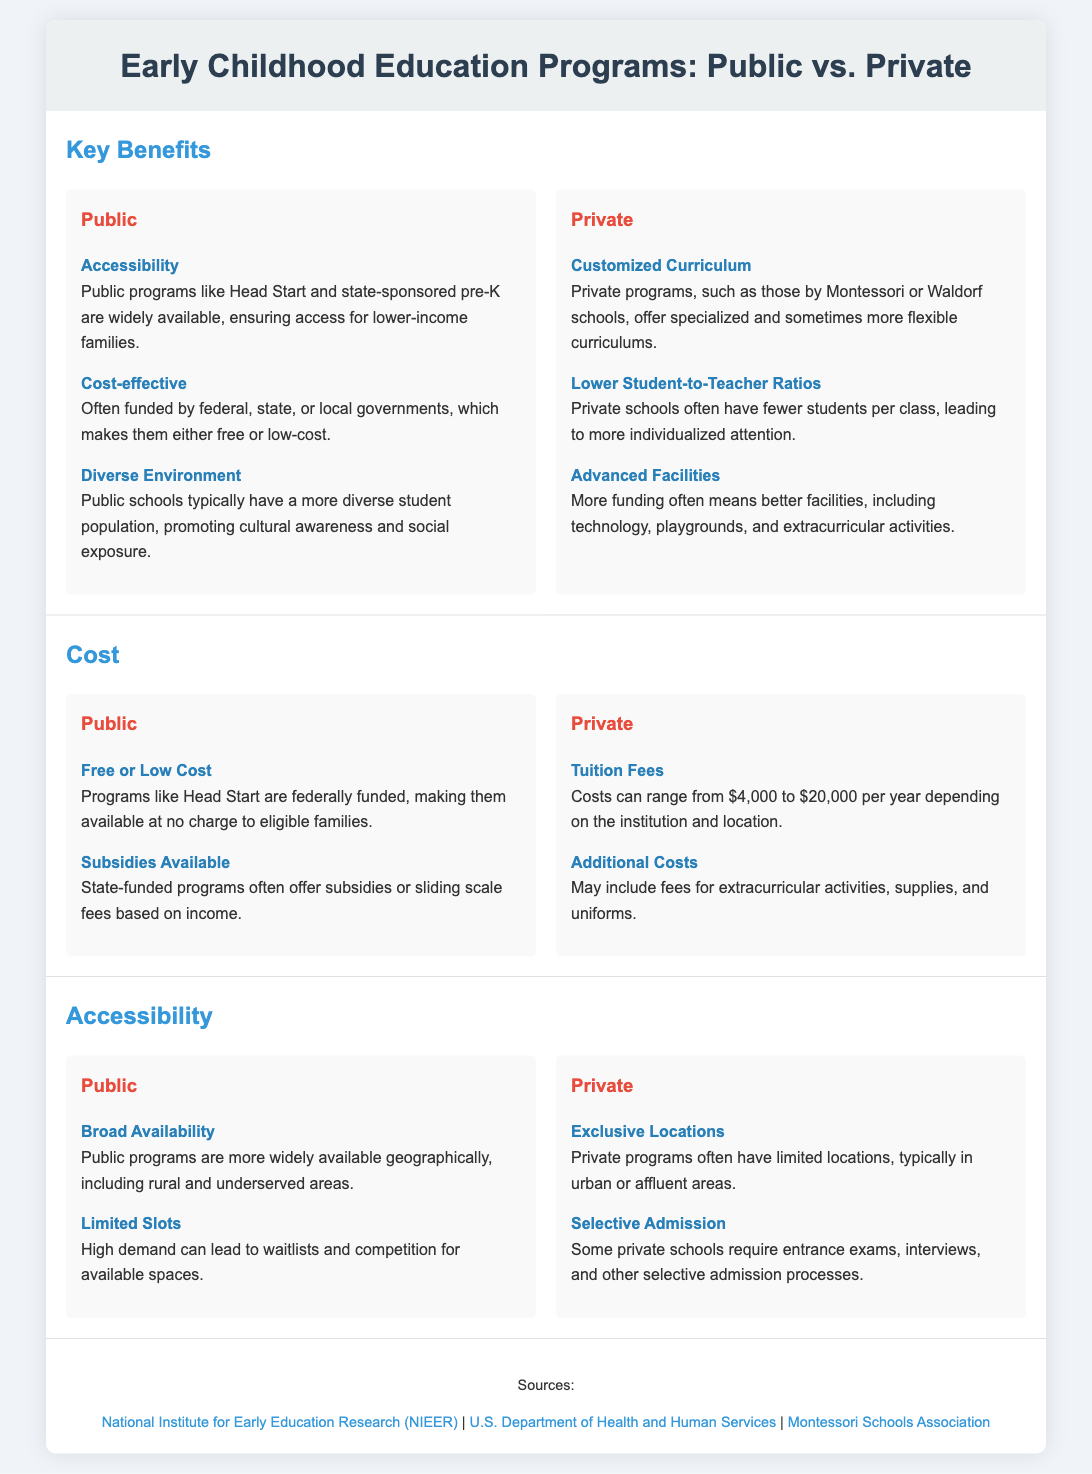What is a key benefit of public programs? The benefits listed for public programs include Accessibility, Cost-effective, and Diverse Environment.
Answer: Accessibility What is the range of tuition fees for private programs? The document states that costs can range from $4,000 to $20,000 per year depending on the institution and location.
Answer: $4,000 to $20,000 What type of curriculum do private programs typically offer? One of the benefits listed for private programs is that they offer Customized Curriculum, which can be specialized or more flexible.
Answer: Customized Curriculum How do public programs ensure accessibility? Public programs like Head Start and state-sponsored pre-K are widely available, ensuring access for lower-income families.
Answer: Lower-income families What is a disadvantage of public programs mentioned in the document? Limited Slots is mentioned, indicating that high demand can lead to waitlists and competition for available spaces.
Answer: Limited Slots What advantage do private programs have regarding student-to-teacher ratios? The document mentions that private schools often have fewer students per class, leading to more individualized attention.
Answer: Lower Student-to-Teacher Ratios Which type of education program usually has more advanced facilities? The text indicates that private education programs, due to more funding, often have better facilities and resources.
Answer: Private How does public program funding typically work? Public programs are often funded by federal, state, or local governments, making them free or low-cost.
Answer: Government funding In terms of geographical availability, how do public programs compare to private ones? Public programs are more widely available geographically, including rural and underserved areas, unlike private programs.
Answer: Widely available 